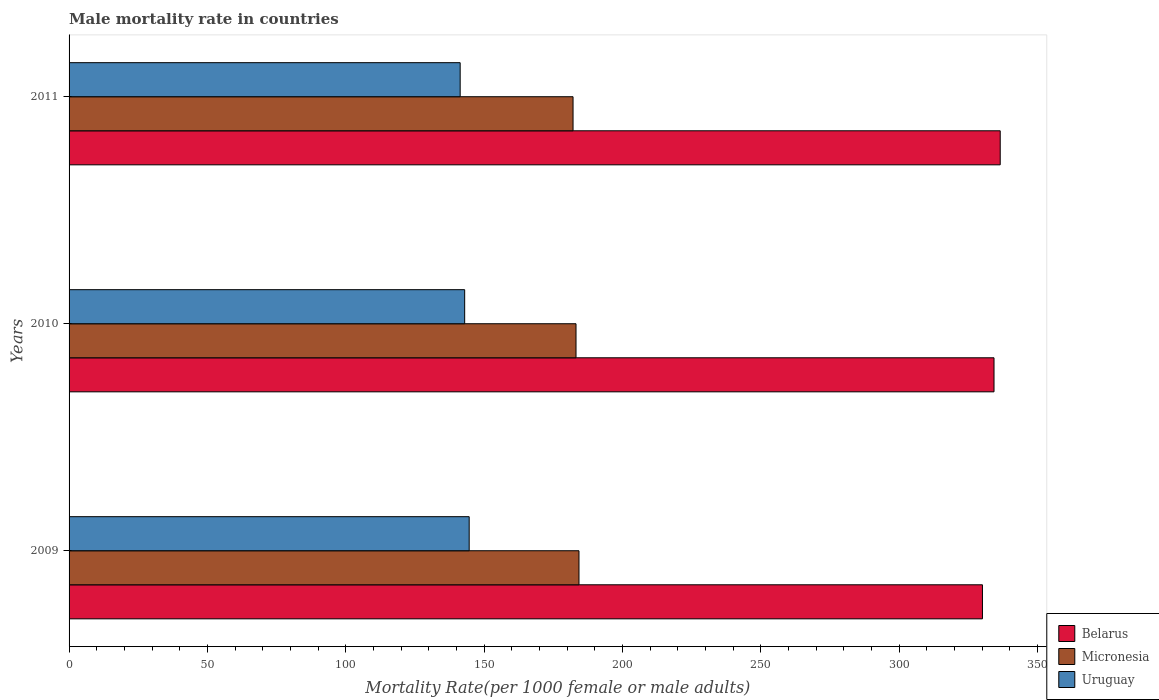Are the number of bars per tick equal to the number of legend labels?
Ensure brevity in your answer.  Yes. How many bars are there on the 1st tick from the top?
Offer a very short reply. 3. What is the label of the 1st group of bars from the top?
Ensure brevity in your answer.  2011. In how many cases, is the number of bars for a given year not equal to the number of legend labels?
Your answer should be very brief. 0. What is the male mortality rate in Uruguay in 2009?
Offer a terse response. 144.59. Across all years, what is the maximum male mortality rate in Belarus?
Keep it short and to the point. 336.49. Across all years, what is the minimum male mortality rate in Uruguay?
Your answer should be compact. 141.34. In which year was the male mortality rate in Belarus minimum?
Make the answer very short. 2009. What is the total male mortality rate in Uruguay in the graph?
Give a very brief answer. 428.89. What is the difference between the male mortality rate in Belarus in 2009 and that in 2010?
Offer a very short reply. -4.17. What is the difference between the male mortality rate in Uruguay in 2009 and the male mortality rate in Micronesia in 2011?
Offer a very short reply. -37.54. What is the average male mortality rate in Uruguay per year?
Provide a short and direct response. 142.96. In the year 2011, what is the difference between the male mortality rate in Belarus and male mortality rate in Uruguay?
Ensure brevity in your answer.  195.16. In how many years, is the male mortality rate in Belarus greater than 40 ?
Ensure brevity in your answer.  3. What is the ratio of the male mortality rate in Uruguay in 2010 to that in 2011?
Offer a terse response. 1.01. What is the difference between the highest and the second highest male mortality rate in Belarus?
Give a very brief answer. 2.24. What is the difference between the highest and the lowest male mortality rate in Belarus?
Provide a succinct answer. 6.42. In how many years, is the male mortality rate in Uruguay greater than the average male mortality rate in Uruguay taken over all years?
Your response must be concise. 2. Is the sum of the male mortality rate in Uruguay in 2010 and 2011 greater than the maximum male mortality rate in Micronesia across all years?
Make the answer very short. Yes. What does the 2nd bar from the top in 2009 represents?
Ensure brevity in your answer.  Micronesia. What does the 2nd bar from the bottom in 2010 represents?
Give a very brief answer. Micronesia. How many bars are there?
Your response must be concise. 9. Are all the bars in the graph horizontal?
Provide a short and direct response. Yes. Are the values on the major ticks of X-axis written in scientific E-notation?
Your answer should be compact. No. Does the graph contain any zero values?
Give a very brief answer. No. Does the graph contain grids?
Provide a short and direct response. No. Where does the legend appear in the graph?
Your answer should be compact. Bottom right. How many legend labels are there?
Make the answer very short. 3. How are the legend labels stacked?
Make the answer very short. Vertical. What is the title of the graph?
Give a very brief answer. Male mortality rate in countries. Does "OECD members" appear as one of the legend labels in the graph?
Keep it short and to the point. No. What is the label or title of the X-axis?
Offer a very short reply. Mortality Rate(per 1000 female or male adults). What is the Mortality Rate(per 1000 female or male adults) in Belarus in 2009?
Give a very brief answer. 330.08. What is the Mortality Rate(per 1000 female or male adults) in Micronesia in 2009?
Offer a very short reply. 184.27. What is the Mortality Rate(per 1000 female or male adults) of Uruguay in 2009?
Give a very brief answer. 144.59. What is the Mortality Rate(per 1000 female or male adults) in Belarus in 2010?
Give a very brief answer. 334.25. What is the Mortality Rate(per 1000 female or male adults) in Micronesia in 2010?
Give a very brief answer. 183.2. What is the Mortality Rate(per 1000 female or male adults) in Uruguay in 2010?
Provide a short and direct response. 142.96. What is the Mortality Rate(per 1000 female or male adults) in Belarus in 2011?
Your answer should be compact. 336.49. What is the Mortality Rate(per 1000 female or male adults) of Micronesia in 2011?
Your answer should be very brief. 182.13. What is the Mortality Rate(per 1000 female or male adults) in Uruguay in 2011?
Keep it short and to the point. 141.34. Across all years, what is the maximum Mortality Rate(per 1000 female or male adults) in Belarus?
Your answer should be compact. 336.49. Across all years, what is the maximum Mortality Rate(per 1000 female or male adults) of Micronesia?
Your response must be concise. 184.27. Across all years, what is the maximum Mortality Rate(per 1000 female or male adults) of Uruguay?
Ensure brevity in your answer.  144.59. Across all years, what is the minimum Mortality Rate(per 1000 female or male adults) of Belarus?
Your response must be concise. 330.08. Across all years, what is the minimum Mortality Rate(per 1000 female or male adults) of Micronesia?
Your response must be concise. 182.13. Across all years, what is the minimum Mortality Rate(per 1000 female or male adults) in Uruguay?
Your answer should be very brief. 141.34. What is the total Mortality Rate(per 1000 female or male adults) in Belarus in the graph?
Ensure brevity in your answer.  1000.82. What is the total Mortality Rate(per 1000 female or male adults) in Micronesia in the graph?
Your answer should be very brief. 549.6. What is the total Mortality Rate(per 1000 female or male adults) of Uruguay in the graph?
Your answer should be very brief. 428.89. What is the difference between the Mortality Rate(per 1000 female or male adults) in Belarus in 2009 and that in 2010?
Make the answer very short. -4.17. What is the difference between the Mortality Rate(per 1000 female or male adults) in Micronesia in 2009 and that in 2010?
Your answer should be very brief. 1.07. What is the difference between the Mortality Rate(per 1000 female or male adults) of Uruguay in 2009 and that in 2010?
Give a very brief answer. 1.63. What is the difference between the Mortality Rate(per 1000 female or male adults) in Belarus in 2009 and that in 2011?
Provide a short and direct response. -6.42. What is the difference between the Mortality Rate(per 1000 female or male adults) of Micronesia in 2009 and that in 2011?
Give a very brief answer. 2.14. What is the difference between the Mortality Rate(per 1000 female or male adults) of Uruguay in 2009 and that in 2011?
Make the answer very short. 3.25. What is the difference between the Mortality Rate(per 1000 female or male adults) in Belarus in 2010 and that in 2011?
Offer a terse response. -2.24. What is the difference between the Mortality Rate(per 1000 female or male adults) in Micronesia in 2010 and that in 2011?
Provide a short and direct response. 1.07. What is the difference between the Mortality Rate(per 1000 female or male adults) in Uruguay in 2010 and that in 2011?
Your response must be concise. 1.63. What is the difference between the Mortality Rate(per 1000 female or male adults) of Belarus in 2009 and the Mortality Rate(per 1000 female or male adults) of Micronesia in 2010?
Your answer should be compact. 146.88. What is the difference between the Mortality Rate(per 1000 female or male adults) of Belarus in 2009 and the Mortality Rate(per 1000 female or male adults) of Uruguay in 2010?
Your answer should be compact. 187.11. What is the difference between the Mortality Rate(per 1000 female or male adults) in Micronesia in 2009 and the Mortality Rate(per 1000 female or male adults) in Uruguay in 2010?
Offer a very short reply. 41.31. What is the difference between the Mortality Rate(per 1000 female or male adults) of Belarus in 2009 and the Mortality Rate(per 1000 female or male adults) of Micronesia in 2011?
Ensure brevity in your answer.  147.95. What is the difference between the Mortality Rate(per 1000 female or male adults) of Belarus in 2009 and the Mortality Rate(per 1000 female or male adults) of Uruguay in 2011?
Ensure brevity in your answer.  188.74. What is the difference between the Mortality Rate(per 1000 female or male adults) of Micronesia in 2009 and the Mortality Rate(per 1000 female or male adults) of Uruguay in 2011?
Keep it short and to the point. 42.94. What is the difference between the Mortality Rate(per 1000 female or male adults) in Belarus in 2010 and the Mortality Rate(per 1000 female or male adults) in Micronesia in 2011?
Your answer should be very brief. 152.12. What is the difference between the Mortality Rate(per 1000 female or male adults) of Belarus in 2010 and the Mortality Rate(per 1000 female or male adults) of Uruguay in 2011?
Your answer should be very brief. 192.92. What is the difference between the Mortality Rate(per 1000 female or male adults) of Micronesia in 2010 and the Mortality Rate(per 1000 female or male adults) of Uruguay in 2011?
Make the answer very short. 41.86. What is the average Mortality Rate(per 1000 female or male adults) of Belarus per year?
Give a very brief answer. 333.61. What is the average Mortality Rate(per 1000 female or male adults) of Micronesia per year?
Provide a short and direct response. 183.2. What is the average Mortality Rate(per 1000 female or male adults) in Uruguay per year?
Your answer should be compact. 142.96. In the year 2009, what is the difference between the Mortality Rate(per 1000 female or male adults) in Belarus and Mortality Rate(per 1000 female or male adults) in Micronesia?
Make the answer very short. 145.81. In the year 2009, what is the difference between the Mortality Rate(per 1000 female or male adults) of Belarus and Mortality Rate(per 1000 female or male adults) of Uruguay?
Your answer should be very brief. 185.49. In the year 2009, what is the difference between the Mortality Rate(per 1000 female or male adults) of Micronesia and Mortality Rate(per 1000 female or male adults) of Uruguay?
Your response must be concise. 39.68. In the year 2010, what is the difference between the Mortality Rate(per 1000 female or male adults) of Belarus and Mortality Rate(per 1000 female or male adults) of Micronesia?
Keep it short and to the point. 151.05. In the year 2010, what is the difference between the Mortality Rate(per 1000 female or male adults) of Belarus and Mortality Rate(per 1000 female or male adults) of Uruguay?
Offer a very short reply. 191.29. In the year 2010, what is the difference between the Mortality Rate(per 1000 female or male adults) in Micronesia and Mortality Rate(per 1000 female or male adults) in Uruguay?
Offer a very short reply. 40.24. In the year 2011, what is the difference between the Mortality Rate(per 1000 female or male adults) in Belarus and Mortality Rate(per 1000 female or male adults) in Micronesia?
Your response must be concise. 154.37. In the year 2011, what is the difference between the Mortality Rate(per 1000 female or male adults) in Belarus and Mortality Rate(per 1000 female or male adults) in Uruguay?
Your answer should be very brief. 195.16. In the year 2011, what is the difference between the Mortality Rate(per 1000 female or male adults) in Micronesia and Mortality Rate(per 1000 female or male adults) in Uruguay?
Provide a short and direct response. 40.79. What is the ratio of the Mortality Rate(per 1000 female or male adults) in Belarus in 2009 to that in 2010?
Offer a terse response. 0.99. What is the ratio of the Mortality Rate(per 1000 female or male adults) of Micronesia in 2009 to that in 2010?
Offer a very short reply. 1.01. What is the ratio of the Mortality Rate(per 1000 female or male adults) in Uruguay in 2009 to that in 2010?
Your answer should be very brief. 1.01. What is the ratio of the Mortality Rate(per 1000 female or male adults) of Belarus in 2009 to that in 2011?
Your response must be concise. 0.98. What is the ratio of the Mortality Rate(per 1000 female or male adults) of Micronesia in 2009 to that in 2011?
Make the answer very short. 1.01. What is the ratio of the Mortality Rate(per 1000 female or male adults) of Belarus in 2010 to that in 2011?
Your answer should be compact. 0.99. What is the ratio of the Mortality Rate(per 1000 female or male adults) of Micronesia in 2010 to that in 2011?
Provide a short and direct response. 1.01. What is the ratio of the Mortality Rate(per 1000 female or male adults) in Uruguay in 2010 to that in 2011?
Make the answer very short. 1.01. What is the difference between the highest and the second highest Mortality Rate(per 1000 female or male adults) of Belarus?
Provide a short and direct response. 2.24. What is the difference between the highest and the second highest Mortality Rate(per 1000 female or male adults) in Micronesia?
Provide a succinct answer. 1.07. What is the difference between the highest and the second highest Mortality Rate(per 1000 female or male adults) of Uruguay?
Your response must be concise. 1.63. What is the difference between the highest and the lowest Mortality Rate(per 1000 female or male adults) in Belarus?
Offer a very short reply. 6.42. What is the difference between the highest and the lowest Mortality Rate(per 1000 female or male adults) of Micronesia?
Ensure brevity in your answer.  2.14. What is the difference between the highest and the lowest Mortality Rate(per 1000 female or male adults) in Uruguay?
Give a very brief answer. 3.25. 